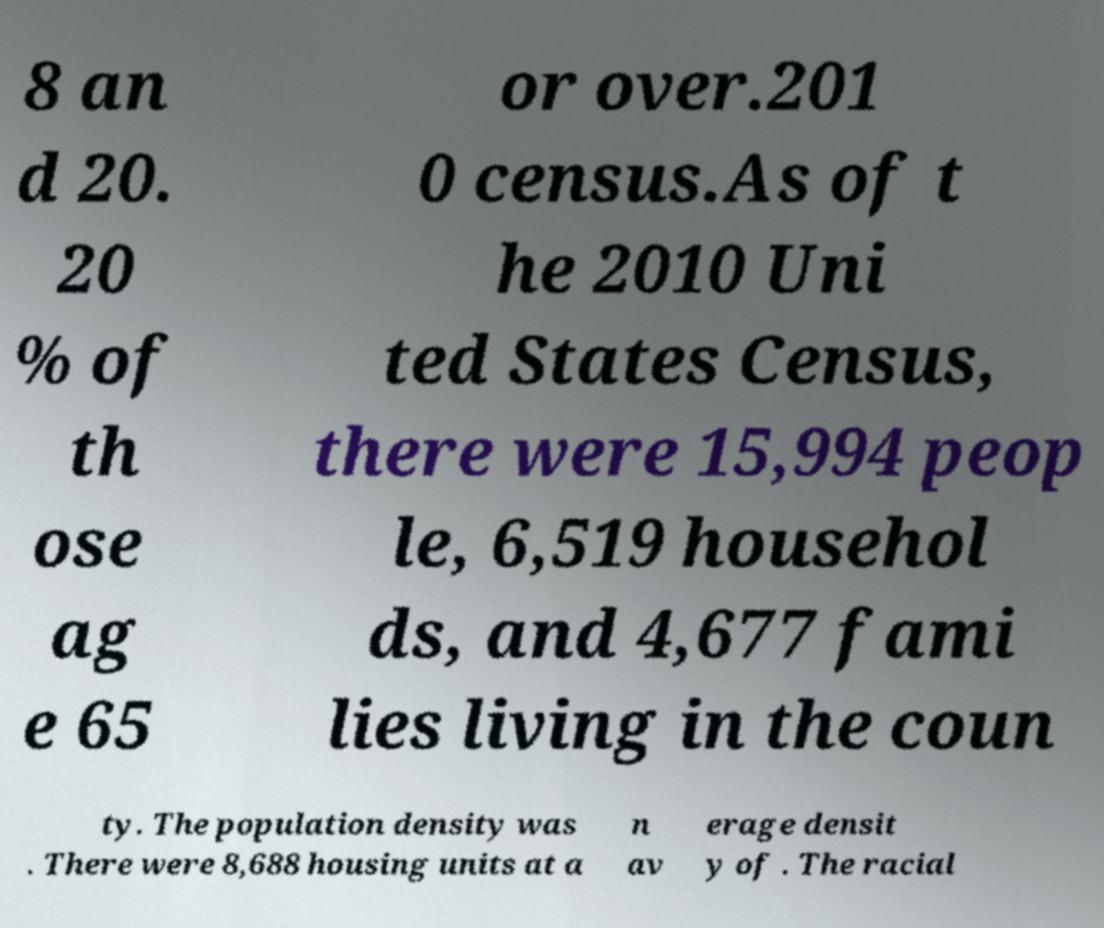For documentation purposes, I need the text within this image transcribed. Could you provide that? 8 an d 20. 20 % of th ose ag e 65 or over.201 0 census.As of t he 2010 Uni ted States Census, there were 15,994 peop le, 6,519 househol ds, and 4,677 fami lies living in the coun ty. The population density was . There were 8,688 housing units at a n av erage densit y of . The racial 